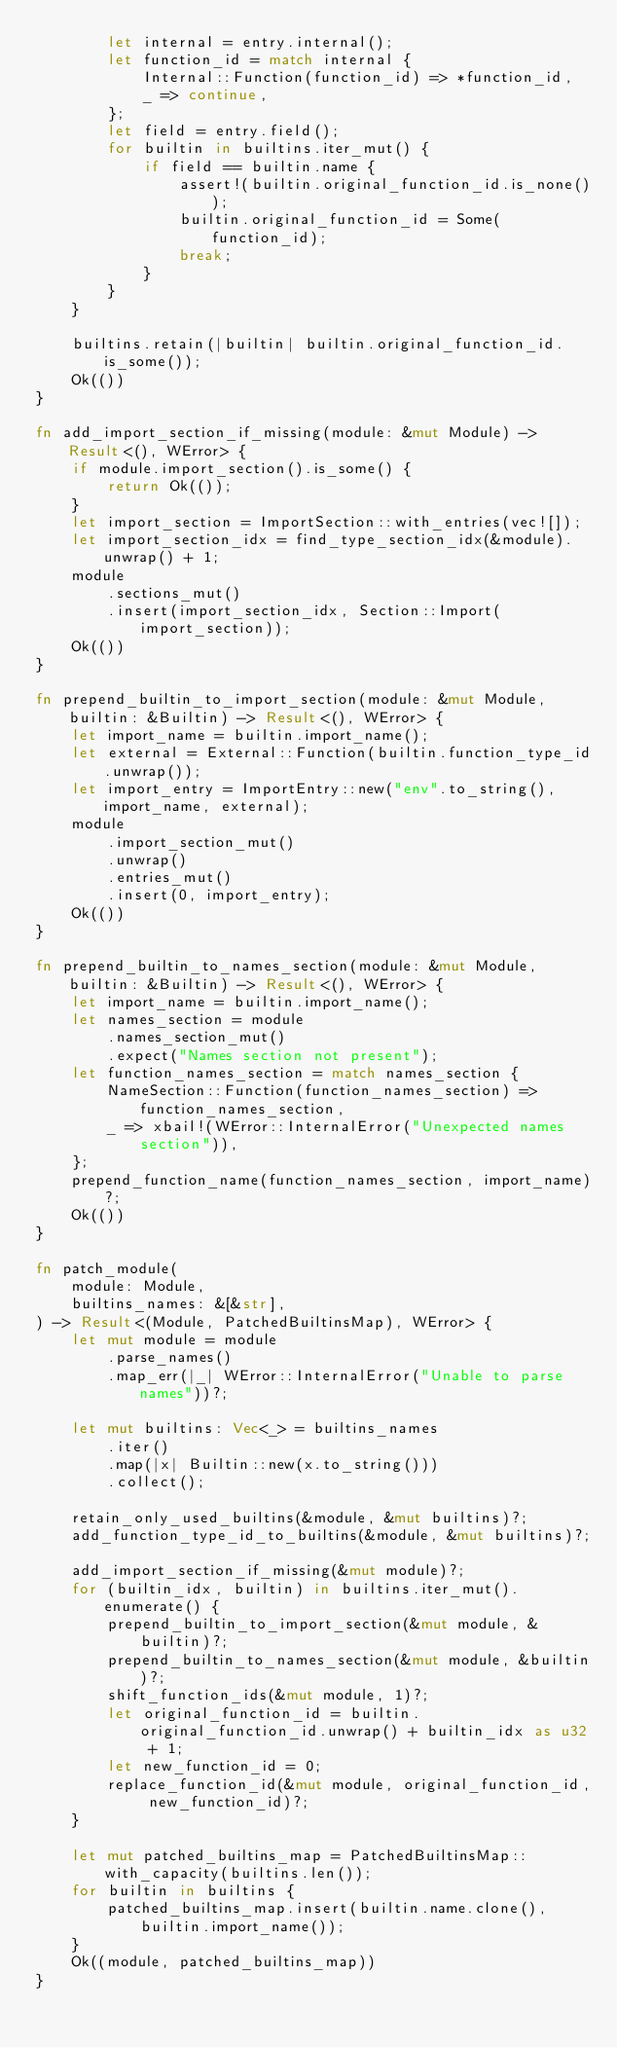<code> <loc_0><loc_0><loc_500><loc_500><_Rust_>        let internal = entry.internal();
        let function_id = match internal {
            Internal::Function(function_id) => *function_id,
            _ => continue,
        };
        let field = entry.field();
        for builtin in builtins.iter_mut() {
            if field == builtin.name {
                assert!(builtin.original_function_id.is_none());
                builtin.original_function_id = Some(function_id);
                break;
            }
        }
    }

    builtins.retain(|builtin| builtin.original_function_id.is_some());
    Ok(())
}

fn add_import_section_if_missing(module: &mut Module) -> Result<(), WError> {
    if module.import_section().is_some() {
        return Ok(());
    }
    let import_section = ImportSection::with_entries(vec![]);
    let import_section_idx = find_type_section_idx(&module).unwrap() + 1;
    module
        .sections_mut()
        .insert(import_section_idx, Section::Import(import_section));
    Ok(())
}

fn prepend_builtin_to_import_section(module: &mut Module, builtin: &Builtin) -> Result<(), WError> {
    let import_name = builtin.import_name();
    let external = External::Function(builtin.function_type_id.unwrap());
    let import_entry = ImportEntry::new("env".to_string(), import_name, external);
    module
        .import_section_mut()
        .unwrap()
        .entries_mut()
        .insert(0, import_entry);
    Ok(())
}

fn prepend_builtin_to_names_section(module: &mut Module, builtin: &Builtin) -> Result<(), WError> {
    let import_name = builtin.import_name();
    let names_section = module
        .names_section_mut()
        .expect("Names section not present");
    let function_names_section = match names_section {
        NameSection::Function(function_names_section) => function_names_section,
        _ => xbail!(WError::InternalError("Unexpected names section")),
    };
    prepend_function_name(function_names_section, import_name)?;
    Ok(())
}

fn patch_module(
    module: Module,
    builtins_names: &[&str],
) -> Result<(Module, PatchedBuiltinsMap), WError> {
    let mut module = module
        .parse_names()
        .map_err(|_| WError::InternalError("Unable to parse names"))?;

    let mut builtins: Vec<_> = builtins_names
        .iter()
        .map(|x| Builtin::new(x.to_string()))
        .collect();

    retain_only_used_builtins(&module, &mut builtins)?;
    add_function_type_id_to_builtins(&module, &mut builtins)?;

    add_import_section_if_missing(&mut module)?;
    for (builtin_idx, builtin) in builtins.iter_mut().enumerate() {
        prepend_builtin_to_import_section(&mut module, &builtin)?;
        prepend_builtin_to_names_section(&mut module, &builtin)?;
        shift_function_ids(&mut module, 1)?;
        let original_function_id = builtin.original_function_id.unwrap() + builtin_idx as u32 + 1;
        let new_function_id = 0;
        replace_function_id(&mut module, original_function_id, new_function_id)?;
    }

    let mut patched_builtins_map = PatchedBuiltinsMap::with_capacity(builtins.len());
    for builtin in builtins {
        patched_builtins_map.insert(builtin.name.clone(), builtin.import_name());
    }
    Ok((module, patched_builtins_map))
}
</code> 